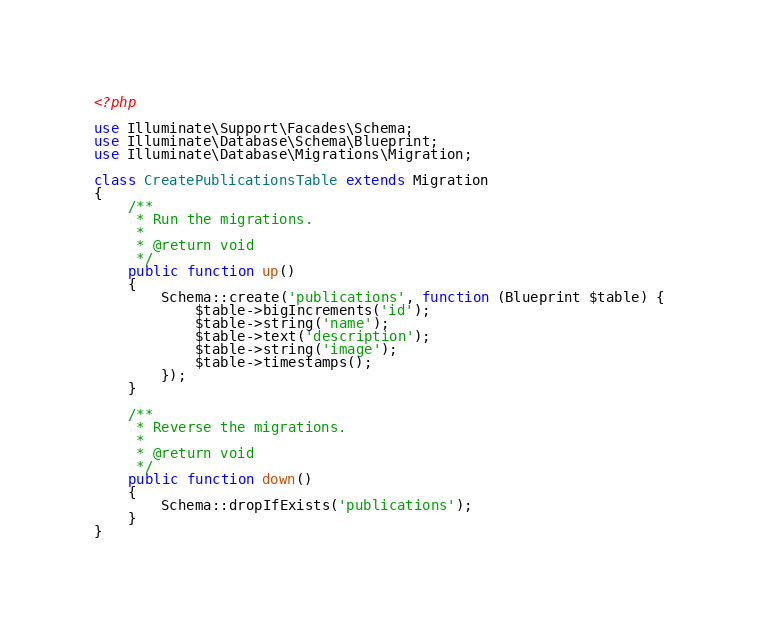Convert code to text. <code><loc_0><loc_0><loc_500><loc_500><_PHP_><?php

use Illuminate\Support\Facades\Schema;
use Illuminate\Database\Schema\Blueprint;
use Illuminate\Database\Migrations\Migration;

class CreatePublicationsTable extends Migration
{
    /**
     * Run the migrations.
     *
     * @return void
     */
    public function up()
    {
        Schema::create('publications', function (Blueprint $table) {
            $table->bigIncrements('id');
            $table->string('name');
            $table->text('description');
            $table->string('image');
            $table->timestamps();
        });
    }

    /**
     * Reverse the migrations.
     *
     * @return void
     */
    public function down()
    {
        Schema::dropIfExists('publications');
    }
}
</code> 